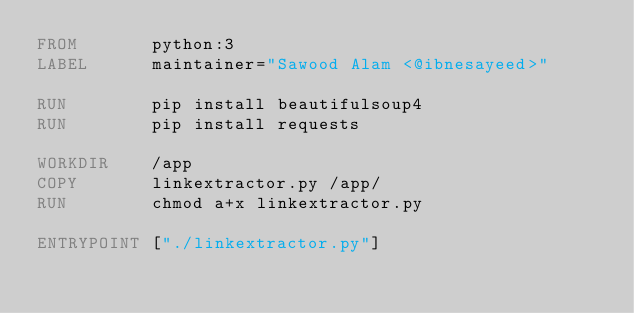<code> <loc_0><loc_0><loc_500><loc_500><_Dockerfile_>FROM       python:3
LABEL      maintainer="Sawood Alam <@ibnesayeed>"

RUN        pip install beautifulsoup4
RUN        pip install requests

WORKDIR    /app
COPY       linkextractor.py /app/
RUN        chmod a+x linkextractor.py

ENTRYPOINT ["./linkextractor.py"]
</code> 